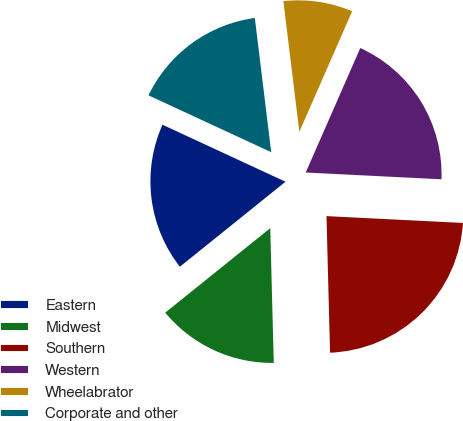Convert chart. <chart><loc_0><loc_0><loc_500><loc_500><pie_chart><fcel>Eastern<fcel>Midwest<fcel>Southern<fcel>Western<fcel>Wheelabrator<fcel>Corporate and other<nl><fcel>17.69%<fcel>14.63%<fcel>23.79%<fcel>19.22%<fcel>8.51%<fcel>16.16%<nl></chart> 